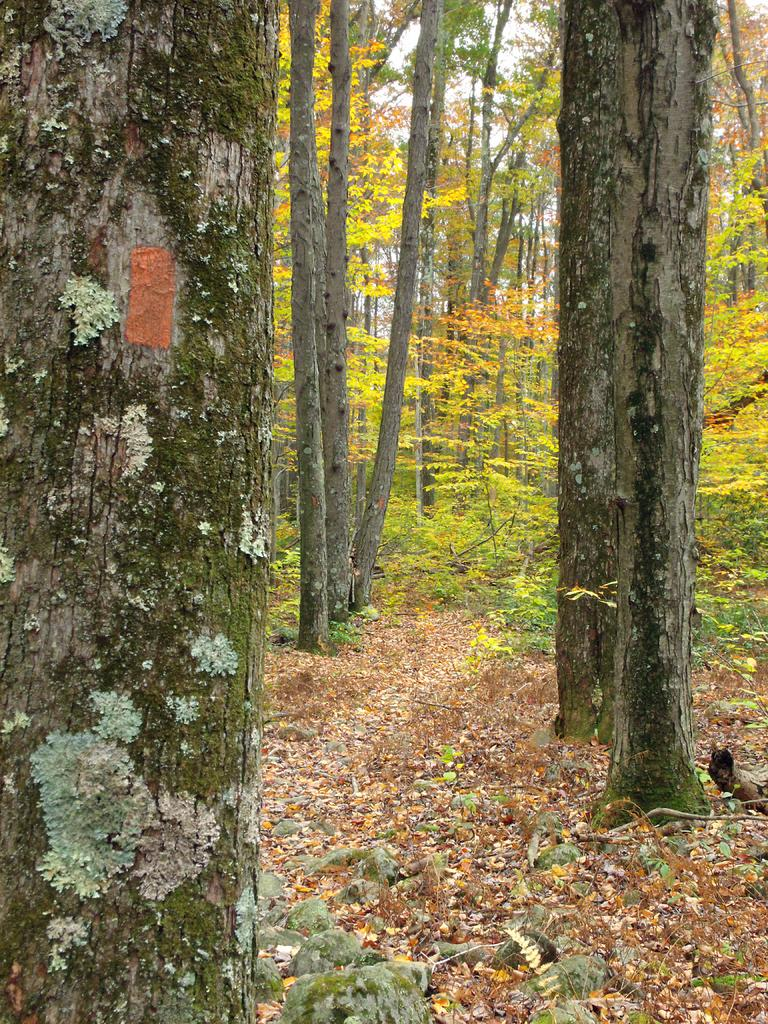What type of vegetation can be seen in the image? There are trees in the image. What is on the ground beneath the trees? Dry leaves are present on the ground. What can be seen in the background of the image? The sky is visible in the background of the image. What type of tools does the carpenter have in the image? There is no carpenter present in the image, so it is not possible to answer that question. 